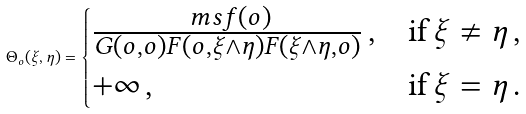<formula> <loc_0><loc_0><loc_500><loc_500>\Theta _ { o } ( \xi , \eta ) = \begin{cases} \frac { \ m s f ( o ) } { G ( o , o ) F ( o , \xi \wedge \eta ) F ( \xi \wedge \eta , o ) } \, , & \text {if} \, \xi \ne \eta \, , \\ + \infty \, , & \text {if} \, \xi = \eta \, . \end{cases}</formula> 